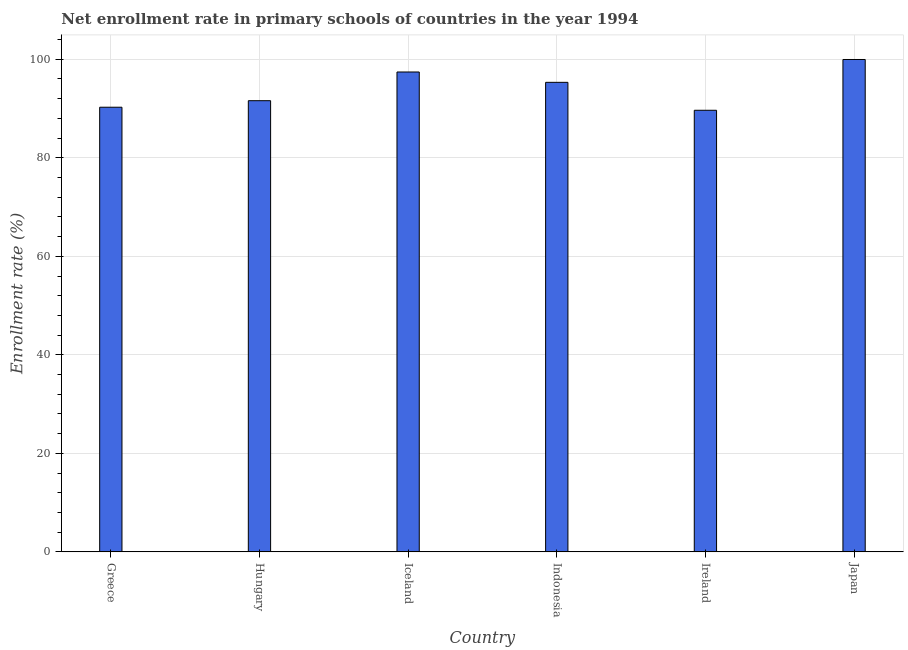Does the graph contain any zero values?
Keep it short and to the point. No. Does the graph contain grids?
Offer a very short reply. Yes. What is the title of the graph?
Give a very brief answer. Net enrollment rate in primary schools of countries in the year 1994. What is the label or title of the X-axis?
Provide a succinct answer. Country. What is the label or title of the Y-axis?
Your response must be concise. Enrollment rate (%). What is the net enrollment rate in primary schools in Ireland?
Offer a very short reply. 89.65. Across all countries, what is the maximum net enrollment rate in primary schools?
Keep it short and to the point. 99.96. Across all countries, what is the minimum net enrollment rate in primary schools?
Offer a very short reply. 89.65. In which country was the net enrollment rate in primary schools maximum?
Your answer should be compact. Japan. In which country was the net enrollment rate in primary schools minimum?
Your answer should be very brief. Ireland. What is the sum of the net enrollment rate in primary schools?
Keep it short and to the point. 564.21. What is the difference between the net enrollment rate in primary schools in Indonesia and Ireland?
Provide a short and direct response. 5.67. What is the average net enrollment rate in primary schools per country?
Your response must be concise. 94.04. What is the median net enrollment rate in primary schools?
Offer a very short reply. 93.46. In how many countries, is the net enrollment rate in primary schools greater than 84 %?
Offer a very short reply. 6. What is the ratio of the net enrollment rate in primary schools in Greece to that in Iceland?
Offer a terse response. 0.93. Is the net enrollment rate in primary schools in Greece less than that in Hungary?
Your answer should be very brief. Yes. Is the difference between the net enrollment rate in primary schools in Greece and Japan greater than the difference between any two countries?
Your response must be concise. No. What is the difference between the highest and the second highest net enrollment rate in primary schools?
Ensure brevity in your answer.  2.54. What is the difference between the highest and the lowest net enrollment rate in primary schools?
Give a very brief answer. 10.31. In how many countries, is the net enrollment rate in primary schools greater than the average net enrollment rate in primary schools taken over all countries?
Your response must be concise. 3. How many bars are there?
Keep it short and to the point. 6. Are the values on the major ticks of Y-axis written in scientific E-notation?
Your answer should be very brief. No. What is the Enrollment rate (%) of Greece?
Give a very brief answer. 90.27. What is the Enrollment rate (%) of Hungary?
Make the answer very short. 91.59. What is the Enrollment rate (%) in Iceland?
Offer a terse response. 97.42. What is the Enrollment rate (%) in Indonesia?
Ensure brevity in your answer.  95.32. What is the Enrollment rate (%) in Ireland?
Offer a terse response. 89.65. What is the Enrollment rate (%) in Japan?
Offer a terse response. 99.96. What is the difference between the Enrollment rate (%) in Greece and Hungary?
Keep it short and to the point. -1.33. What is the difference between the Enrollment rate (%) in Greece and Iceland?
Provide a short and direct response. -7.15. What is the difference between the Enrollment rate (%) in Greece and Indonesia?
Make the answer very short. -5.05. What is the difference between the Enrollment rate (%) in Greece and Ireland?
Provide a succinct answer. 0.62. What is the difference between the Enrollment rate (%) in Greece and Japan?
Offer a very short reply. -9.69. What is the difference between the Enrollment rate (%) in Hungary and Iceland?
Provide a succinct answer. -5.83. What is the difference between the Enrollment rate (%) in Hungary and Indonesia?
Your response must be concise. -3.73. What is the difference between the Enrollment rate (%) in Hungary and Ireland?
Make the answer very short. 1.94. What is the difference between the Enrollment rate (%) in Hungary and Japan?
Provide a succinct answer. -8.36. What is the difference between the Enrollment rate (%) in Iceland and Indonesia?
Your response must be concise. 2.1. What is the difference between the Enrollment rate (%) in Iceland and Ireland?
Your response must be concise. 7.77. What is the difference between the Enrollment rate (%) in Iceland and Japan?
Ensure brevity in your answer.  -2.54. What is the difference between the Enrollment rate (%) in Indonesia and Ireland?
Make the answer very short. 5.67. What is the difference between the Enrollment rate (%) in Indonesia and Japan?
Offer a terse response. -4.64. What is the difference between the Enrollment rate (%) in Ireland and Japan?
Your answer should be very brief. -10.31. What is the ratio of the Enrollment rate (%) in Greece to that in Hungary?
Offer a very short reply. 0.99. What is the ratio of the Enrollment rate (%) in Greece to that in Iceland?
Give a very brief answer. 0.93. What is the ratio of the Enrollment rate (%) in Greece to that in Indonesia?
Give a very brief answer. 0.95. What is the ratio of the Enrollment rate (%) in Greece to that in Ireland?
Keep it short and to the point. 1.01. What is the ratio of the Enrollment rate (%) in Greece to that in Japan?
Provide a succinct answer. 0.9. What is the ratio of the Enrollment rate (%) in Hungary to that in Iceland?
Keep it short and to the point. 0.94. What is the ratio of the Enrollment rate (%) in Hungary to that in Ireland?
Your answer should be very brief. 1.02. What is the ratio of the Enrollment rate (%) in Hungary to that in Japan?
Keep it short and to the point. 0.92. What is the ratio of the Enrollment rate (%) in Iceland to that in Ireland?
Your response must be concise. 1.09. What is the ratio of the Enrollment rate (%) in Iceland to that in Japan?
Provide a short and direct response. 0.97. What is the ratio of the Enrollment rate (%) in Indonesia to that in Ireland?
Ensure brevity in your answer.  1.06. What is the ratio of the Enrollment rate (%) in Indonesia to that in Japan?
Give a very brief answer. 0.95. What is the ratio of the Enrollment rate (%) in Ireland to that in Japan?
Offer a terse response. 0.9. 